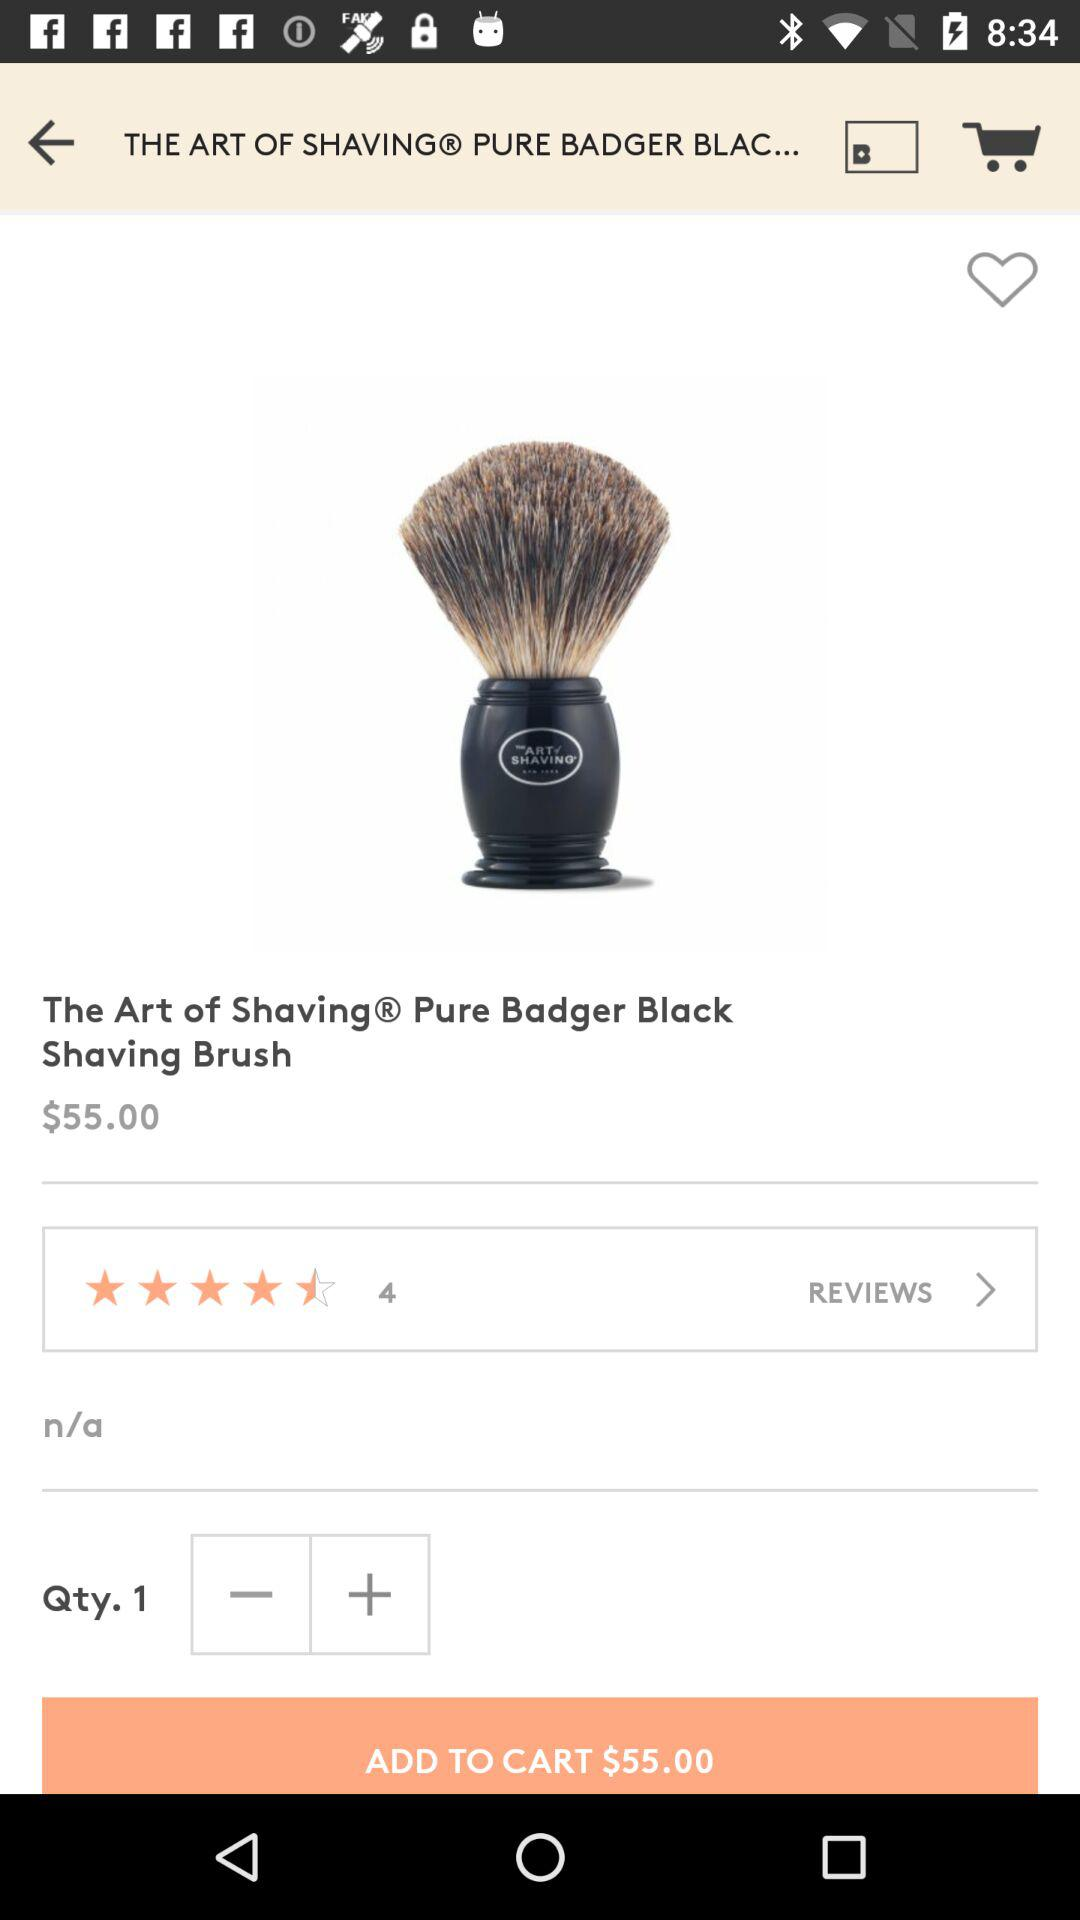What is the total balance in the cart? The total balance is $55.00. 